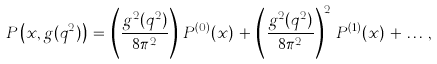<formula> <loc_0><loc_0><loc_500><loc_500>P \left ( x , g ( q ^ { 2 } ) \right ) \, = \, \left ( \frac { g ^ { 2 } ( q ^ { 2 } ) } { 8 \pi ^ { 2 } } \right ) \, P ^ { ( 0 ) } ( x ) \, + \, \left ( \frac { g ^ { 2 } ( q ^ { 2 } ) } { 8 \pi ^ { 2 } } \right ) ^ { 2 } \, P ^ { ( 1 ) } ( x ) \, + \, \dots \, ,</formula> 